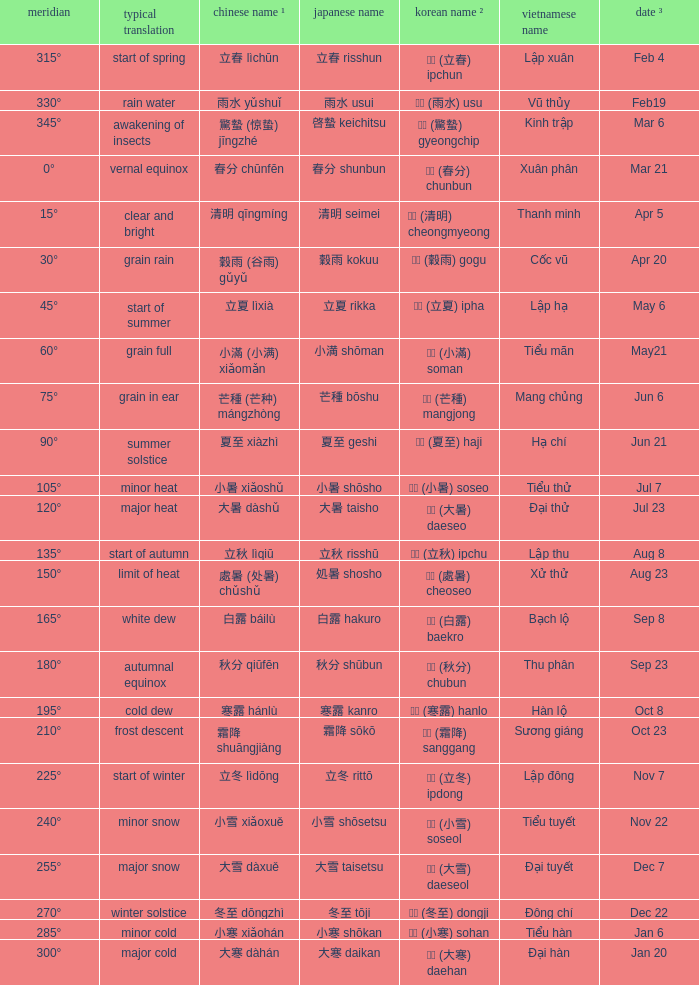Which Longi- tude is on jun 6? 75°. 